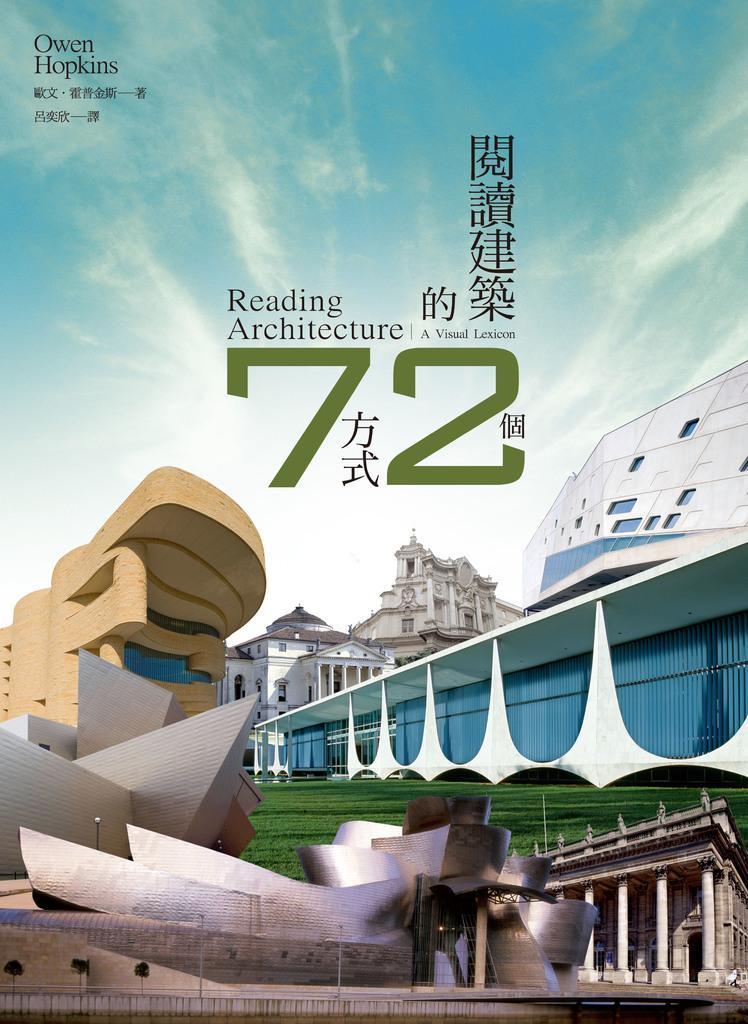In one or two sentences, can you explain what this image depicts? In this image, we can see a magazine. In this magazine, we can see few buildings with walls, pole, grass. Background there is a sky. Here we can see some text. 